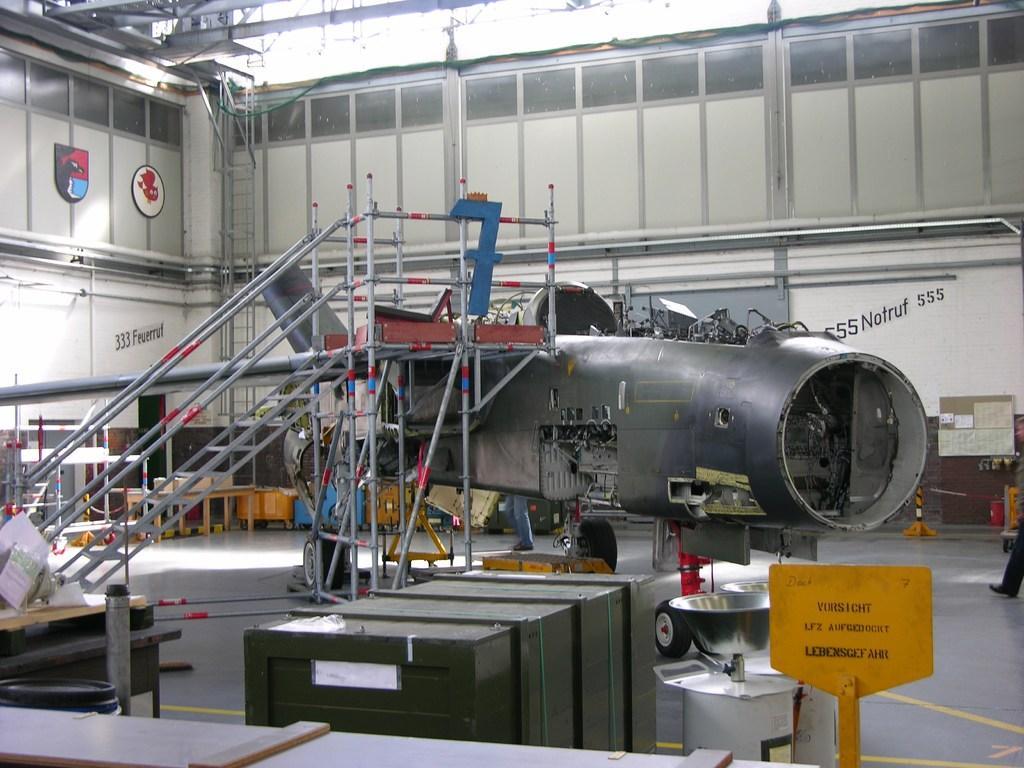Describe this image in one or two sentences. In this picture I can see the construction of an aircraft, there is a staircase, there are ladders, cardboard boxes, tables and some other objects. 